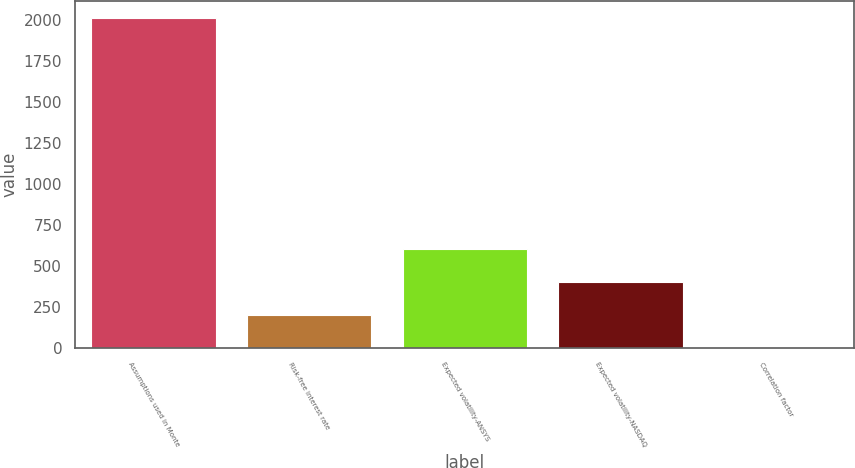Convert chart. <chart><loc_0><loc_0><loc_500><loc_500><bar_chart><fcel>Assumptions used in Monte<fcel>Risk-free interest rate<fcel>Expected volatility-ANSYS<fcel>Expected volatility-NASDAQ<fcel>Correlation factor<nl><fcel>2016<fcel>202.19<fcel>605.26<fcel>403.73<fcel>0.65<nl></chart> 